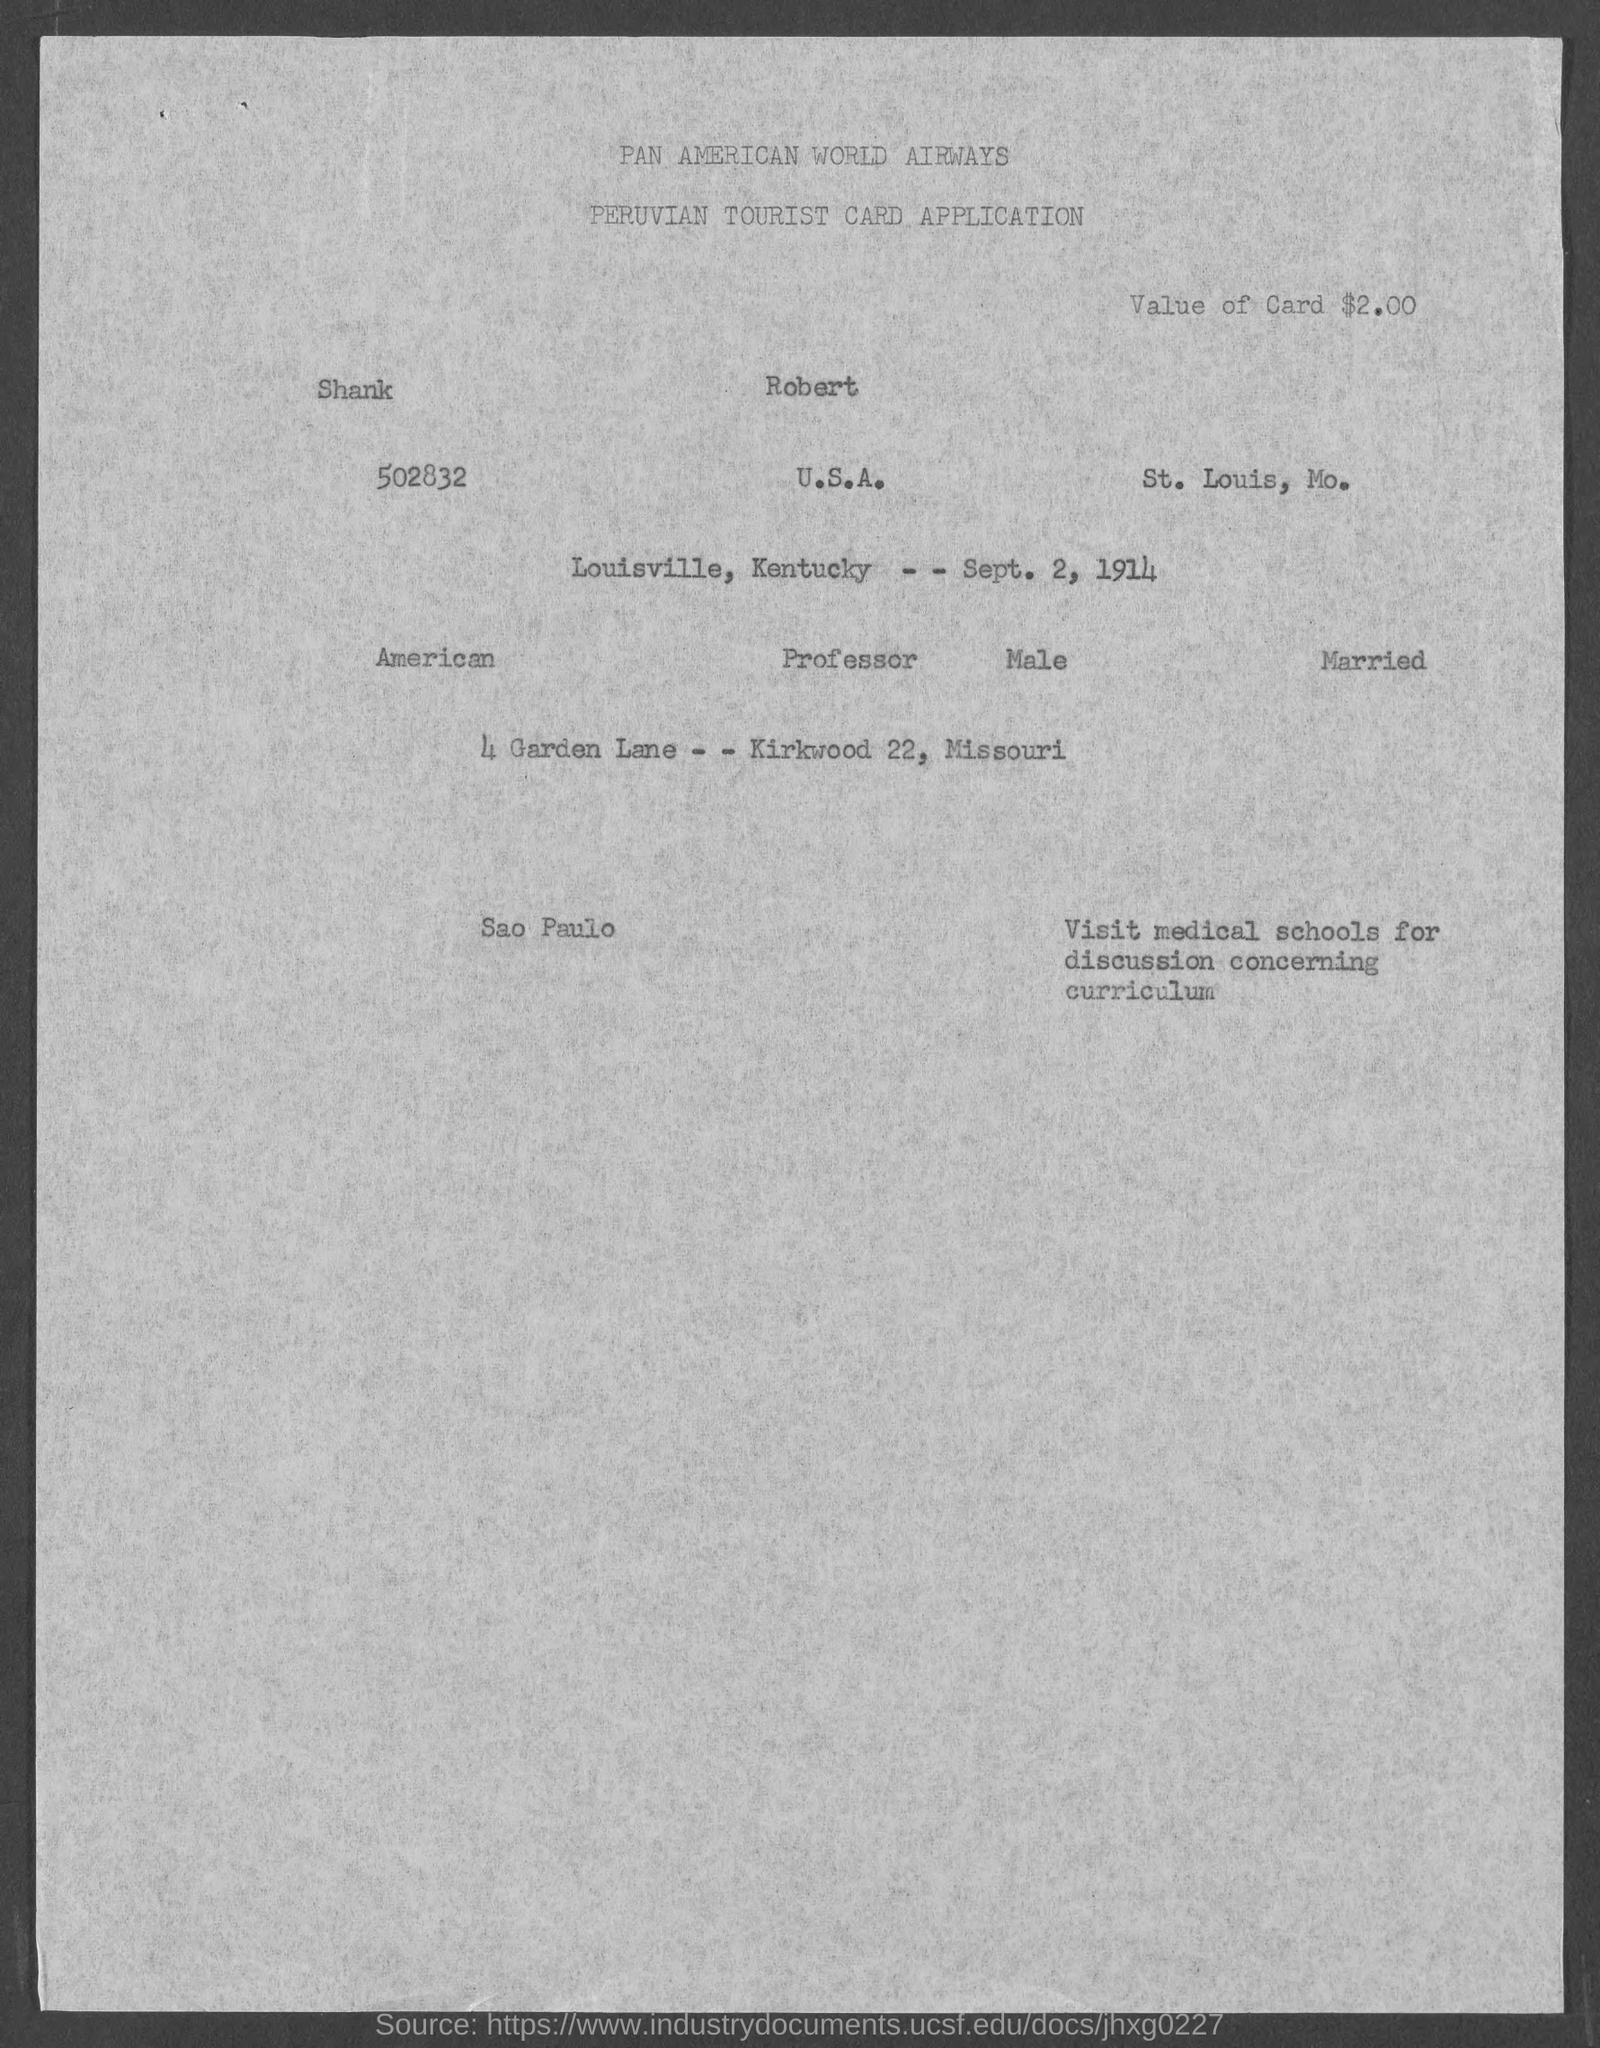Identify some key points in this picture. The value of the card given in the application is two dollars and zero cents. The travel date mentioned in the application is September 2, 1914. 